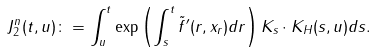<formula> <loc_0><loc_0><loc_500><loc_500>J _ { 2 } ^ { n } ( t , u ) & \colon = \int _ { u } ^ { t } \exp \left ( \int _ { s } ^ { t } \tilde { f } ^ { \prime } ( r , x _ { r } ) d r \right ) K _ { s } \cdot K _ { H } ( s , u ) d s .</formula> 